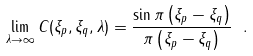<formula> <loc_0><loc_0><loc_500><loc_500>\lim _ { \lambda \to \infty } C ( \xi _ { p } , \xi _ { q } , \lambda ) = \frac { \sin \pi \left ( \xi _ { p } - \xi _ { q } \right ) } { \pi \left ( \xi _ { p } - \xi _ { q } \right ) } \ .</formula> 